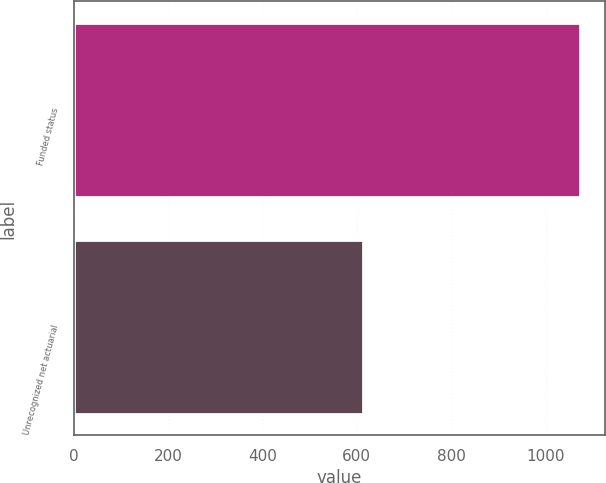Convert chart. <chart><loc_0><loc_0><loc_500><loc_500><bar_chart><fcel>Funded status<fcel>Unrecognized net actuarial<nl><fcel>1072<fcel>613<nl></chart> 